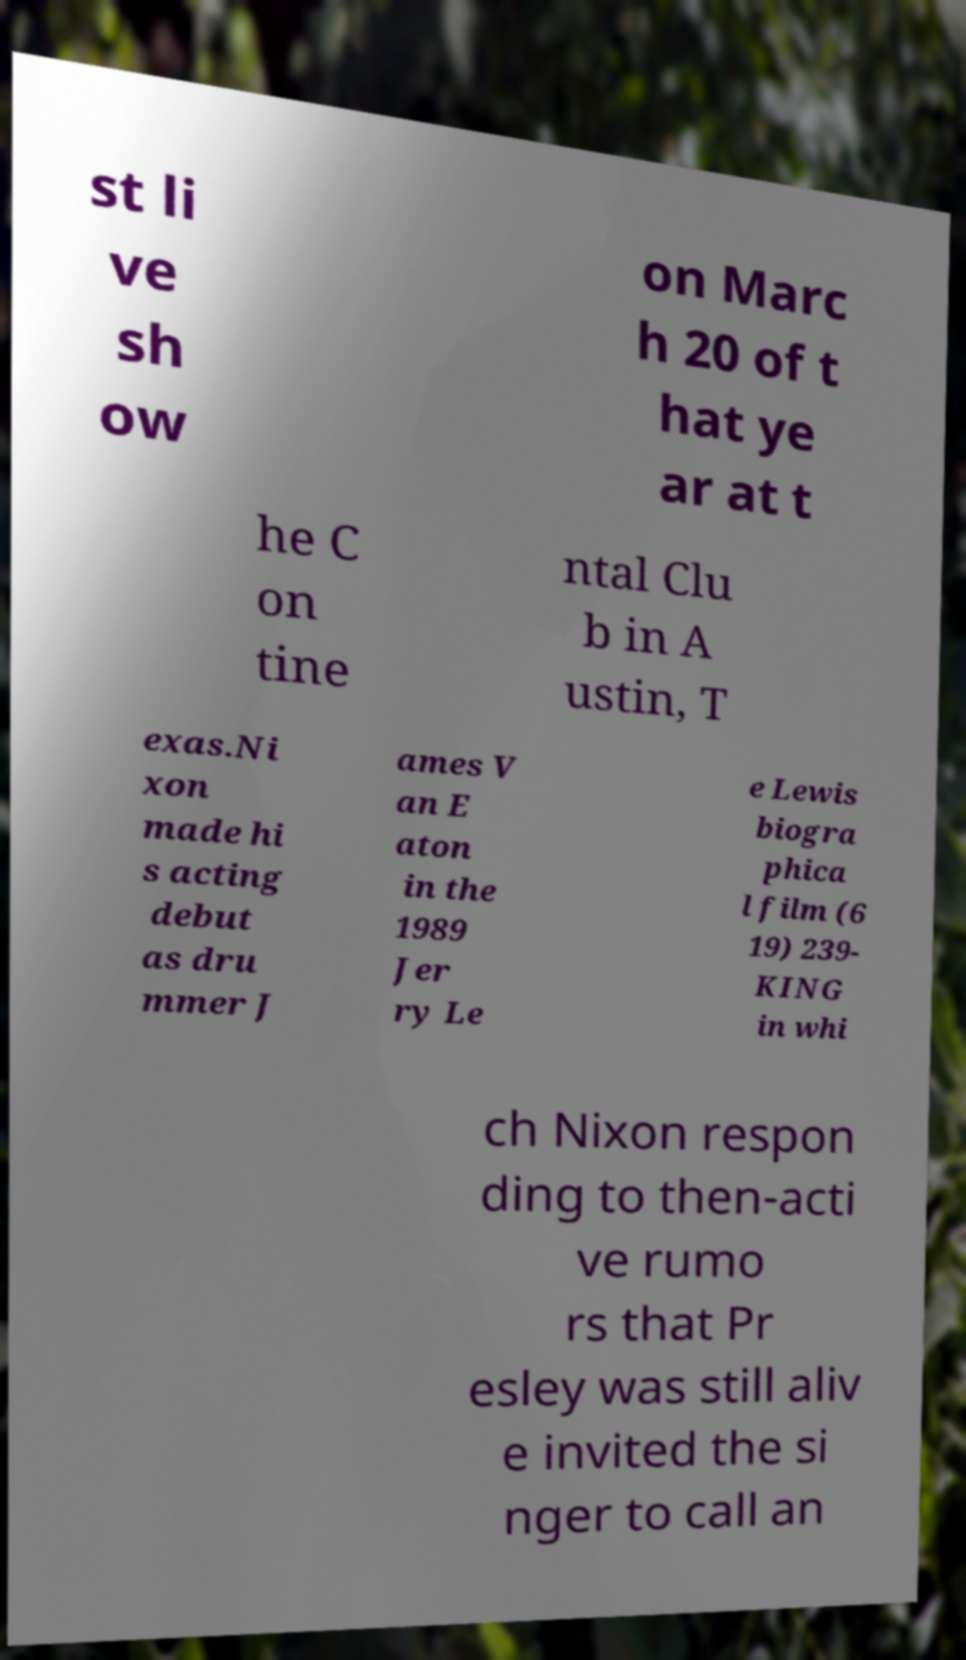Could you extract and type out the text from this image? st li ve sh ow on Marc h 20 of t hat ye ar at t he C on tine ntal Clu b in A ustin, T exas.Ni xon made hi s acting debut as dru mmer J ames V an E aton in the 1989 Jer ry Le e Lewis biogra phica l film (6 19) 239- KING in whi ch Nixon respon ding to then-acti ve rumo rs that Pr esley was still aliv e invited the si nger to call an 